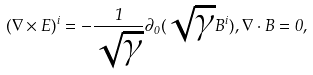Convert formula to latex. <formula><loc_0><loc_0><loc_500><loc_500>( { \nabla \times E } ) ^ { i } = - \frac { 1 } { \sqrt { \gamma } } \partial _ { 0 } ( \sqrt { \gamma } B ^ { i } ) , { \nabla } \cdot { B } = 0 ,</formula> 